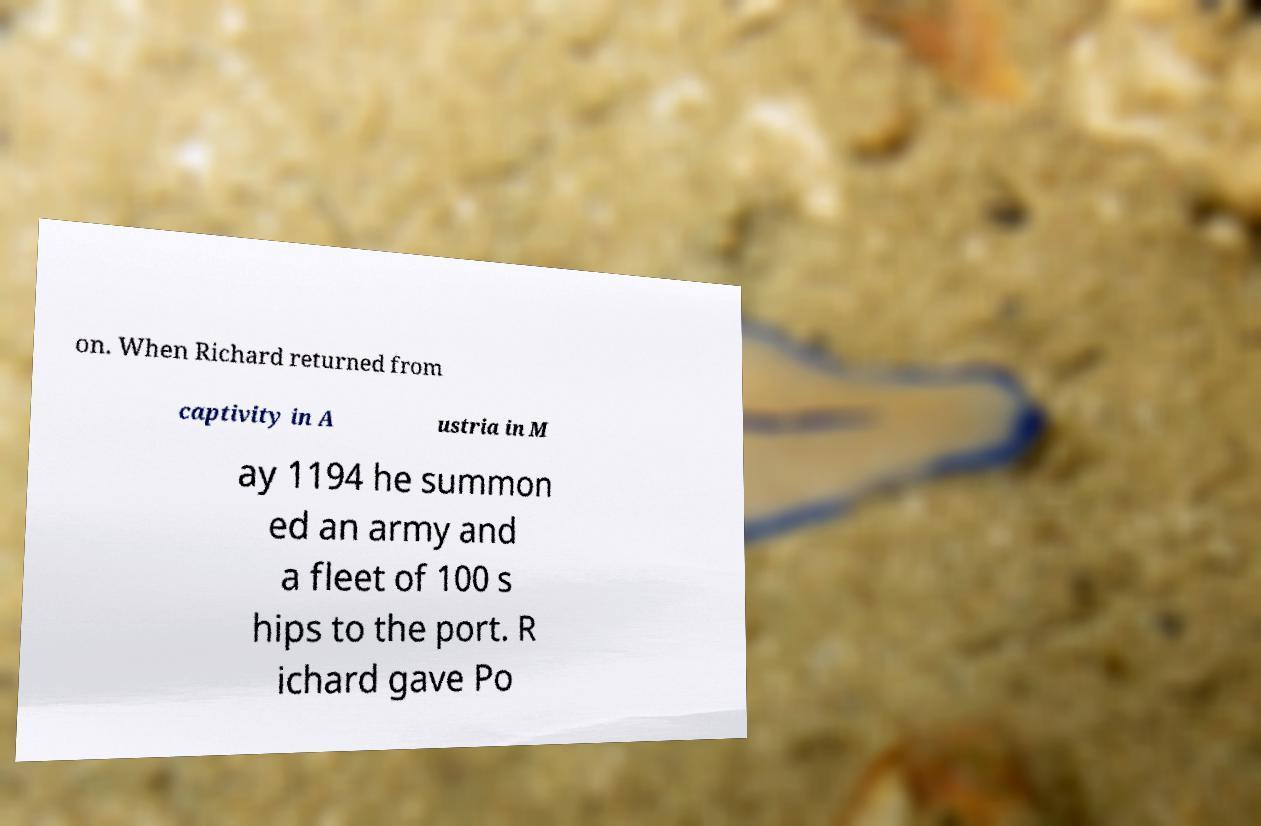I need the written content from this picture converted into text. Can you do that? on. When Richard returned from captivity in A ustria in M ay 1194 he summon ed an army and a fleet of 100 s hips to the port. R ichard gave Po 